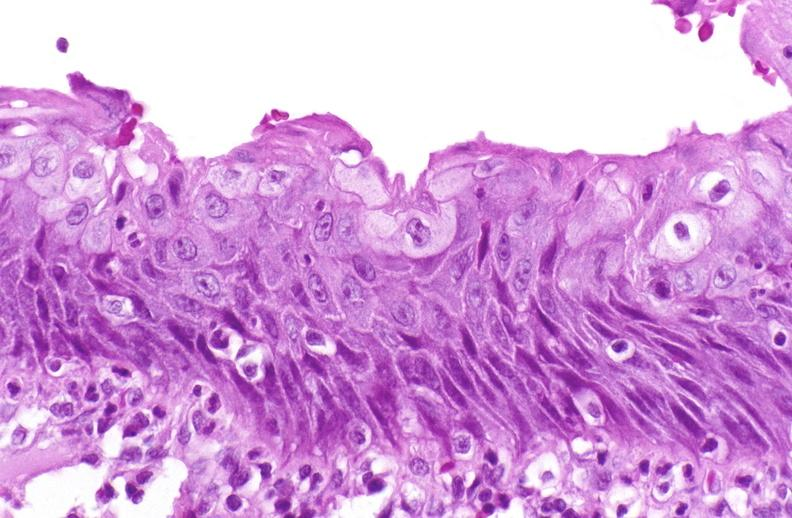what is present?
Answer the question using a single word or phrase. Urinary 